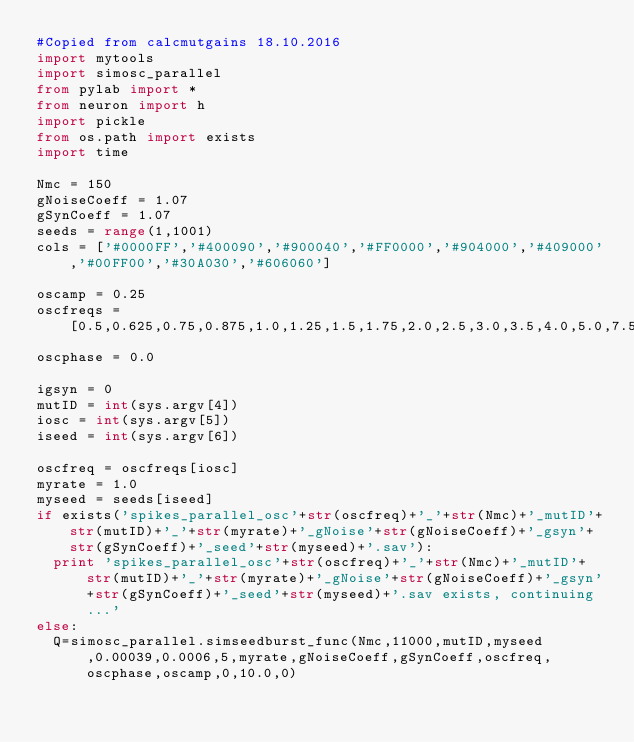<code> <loc_0><loc_0><loc_500><loc_500><_Python_>#Copied from calcmutgains 18.10.2016
import mytools
import simosc_parallel
from pylab import *
from neuron import h
import pickle
from os.path import exists
import time

Nmc = 150
gNoiseCoeff = 1.07
gSynCoeff = 1.07
seeds = range(1,1001)
cols = ['#0000FF','#400090','#900040','#FF0000','#904000','#409000','#00FF00','#30A030','#606060']

oscamp = 0.25
oscfreqs = [0.5,0.625,0.75,0.875,1.0,1.25,1.5,1.75,2.0,2.5,3.0,3.5,4.0,5.0,7.5,10.0,15.0]
oscphase = 0.0

igsyn = 0
mutID = int(sys.argv[4])
iosc = int(sys.argv[5])
iseed = int(sys.argv[6])

oscfreq = oscfreqs[iosc]
myrate = 1.0
myseed = seeds[iseed]
if exists('spikes_parallel_osc'+str(oscfreq)+'_'+str(Nmc)+'_mutID'+str(mutID)+'_'+str(myrate)+'_gNoise'+str(gNoiseCoeff)+'_gsyn'+str(gSynCoeff)+'_seed'+str(myseed)+'.sav'):
  print 'spikes_parallel_osc'+str(oscfreq)+'_'+str(Nmc)+'_mutID'+str(mutID)+'_'+str(myrate)+'_gNoise'+str(gNoiseCoeff)+'_gsyn'+str(gSynCoeff)+'_seed'+str(myseed)+'.sav exists, continuing...'
else:
  Q=simosc_parallel.simseedburst_func(Nmc,11000,mutID,myseed,0.00039,0.0006,5,myrate,gNoiseCoeff,gSynCoeff,oscfreq,oscphase,oscamp,0,10.0,0)
</code> 